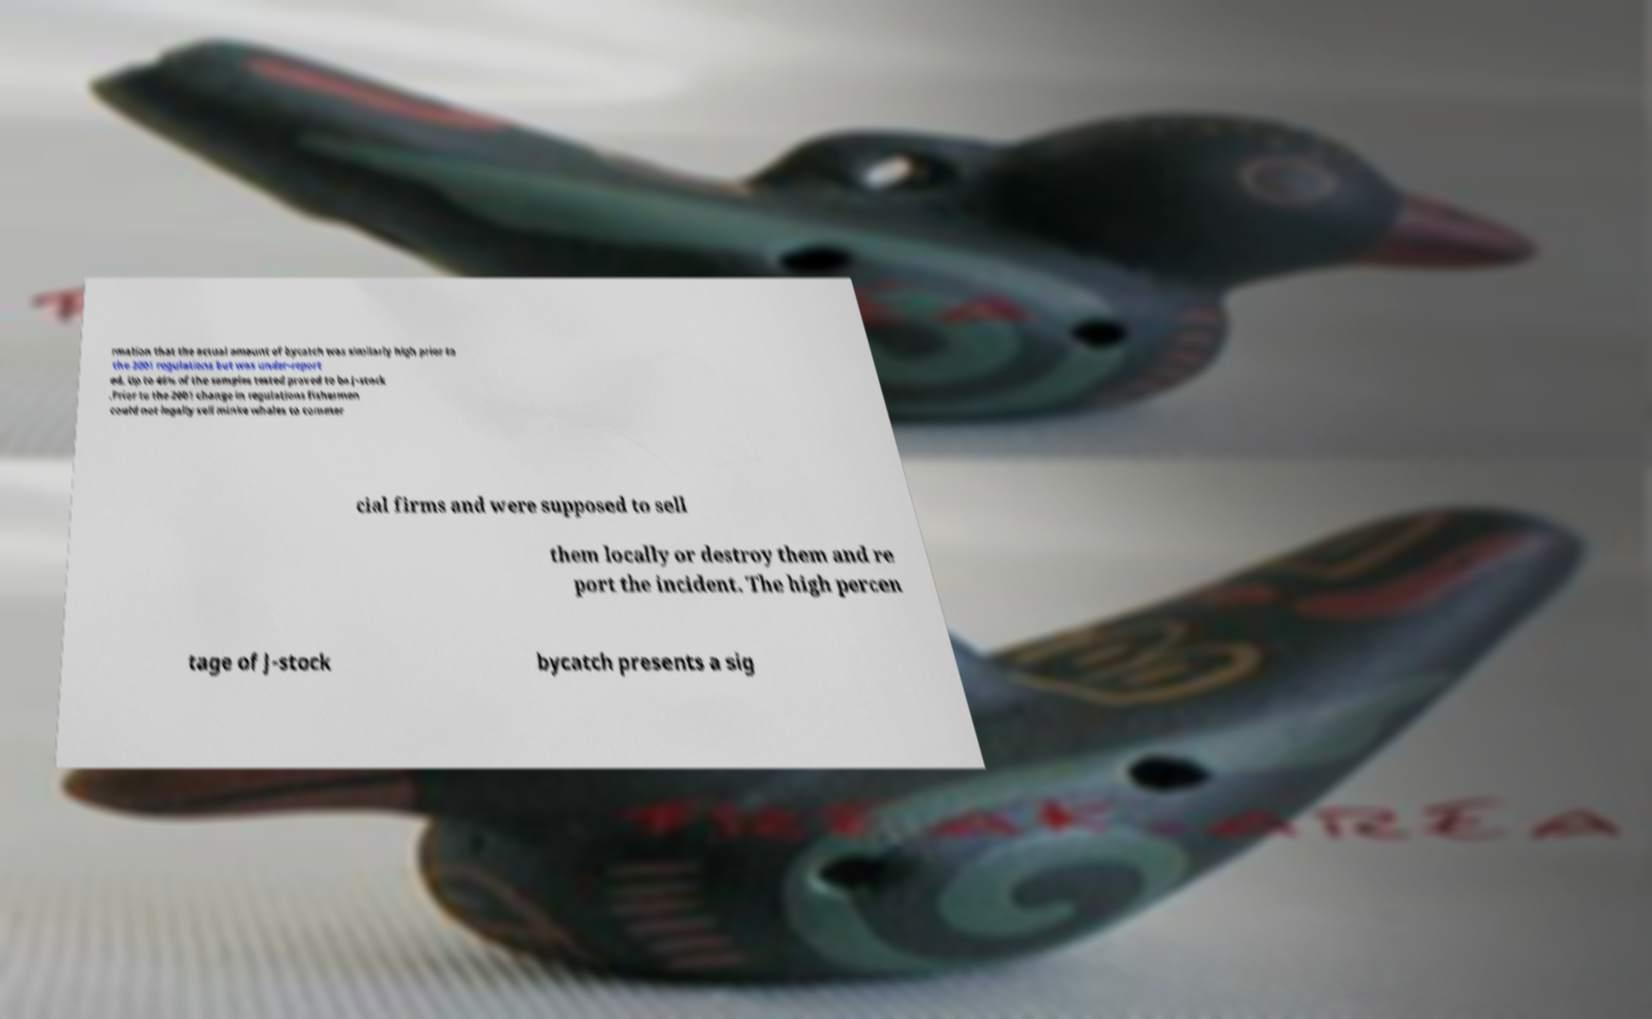Can you accurately transcribe the text from the provided image for me? rmation that the actual amount of bycatch was similarly high prior to the 2001 regulations but was under-report ed. Up to 46% of the samples tested proved to be J-stock .Prior to the 2001 change in regulations fishermen could not legally sell minke whales to commer cial firms and were supposed to sell them locally or destroy them and re port the incident. The high percen tage of J-stock bycatch presents a sig 